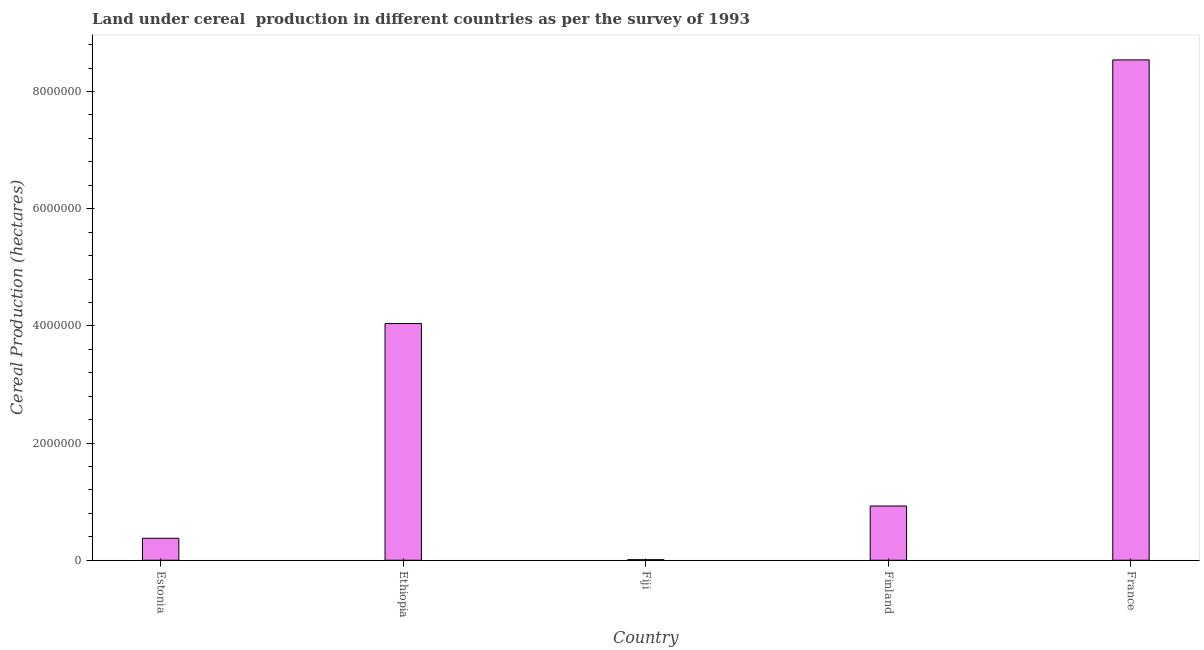Does the graph contain grids?
Keep it short and to the point. No. What is the title of the graph?
Offer a terse response. Land under cereal  production in different countries as per the survey of 1993. What is the label or title of the Y-axis?
Your answer should be compact. Cereal Production (hectares). What is the land under cereal production in Finland?
Provide a short and direct response. 9.26e+05. Across all countries, what is the maximum land under cereal production?
Offer a very short reply. 8.54e+06. Across all countries, what is the minimum land under cereal production?
Provide a short and direct response. 1.00e+04. In which country was the land under cereal production maximum?
Provide a succinct answer. France. In which country was the land under cereal production minimum?
Your response must be concise. Fiji. What is the sum of the land under cereal production?
Provide a short and direct response. 1.39e+07. What is the difference between the land under cereal production in Ethiopia and France?
Offer a very short reply. -4.50e+06. What is the average land under cereal production per country?
Offer a terse response. 2.78e+06. What is the median land under cereal production?
Ensure brevity in your answer.  9.26e+05. In how many countries, is the land under cereal production greater than 6400000 hectares?
Keep it short and to the point. 1. What is the ratio of the land under cereal production in Finland to that in France?
Give a very brief answer. 0.11. Is the difference between the land under cereal production in Ethiopia and Finland greater than the difference between any two countries?
Ensure brevity in your answer.  No. What is the difference between the highest and the second highest land under cereal production?
Ensure brevity in your answer.  4.50e+06. What is the difference between the highest and the lowest land under cereal production?
Your response must be concise. 8.53e+06. In how many countries, is the land under cereal production greater than the average land under cereal production taken over all countries?
Offer a very short reply. 2. Are all the bars in the graph horizontal?
Offer a very short reply. No. How many countries are there in the graph?
Your response must be concise. 5. What is the difference between two consecutive major ticks on the Y-axis?
Offer a very short reply. 2.00e+06. What is the Cereal Production (hectares) of Estonia?
Your answer should be compact. 3.75e+05. What is the Cereal Production (hectares) of Ethiopia?
Make the answer very short. 4.04e+06. What is the Cereal Production (hectares) of Fiji?
Your answer should be very brief. 1.00e+04. What is the Cereal Production (hectares) in Finland?
Make the answer very short. 9.26e+05. What is the Cereal Production (hectares) of France?
Provide a short and direct response. 8.54e+06. What is the difference between the Cereal Production (hectares) in Estonia and Ethiopia?
Offer a very short reply. -3.67e+06. What is the difference between the Cereal Production (hectares) in Estonia and Fiji?
Offer a terse response. 3.65e+05. What is the difference between the Cereal Production (hectares) in Estonia and Finland?
Ensure brevity in your answer.  -5.51e+05. What is the difference between the Cereal Production (hectares) in Estonia and France?
Ensure brevity in your answer.  -8.17e+06. What is the difference between the Cereal Production (hectares) in Ethiopia and Fiji?
Offer a very short reply. 4.03e+06. What is the difference between the Cereal Production (hectares) in Ethiopia and Finland?
Ensure brevity in your answer.  3.11e+06. What is the difference between the Cereal Production (hectares) in Ethiopia and France?
Give a very brief answer. -4.50e+06. What is the difference between the Cereal Production (hectares) in Fiji and Finland?
Offer a very short reply. -9.16e+05. What is the difference between the Cereal Production (hectares) in Fiji and France?
Provide a short and direct response. -8.53e+06. What is the difference between the Cereal Production (hectares) in Finland and France?
Your answer should be very brief. -7.61e+06. What is the ratio of the Cereal Production (hectares) in Estonia to that in Ethiopia?
Your answer should be compact. 0.09. What is the ratio of the Cereal Production (hectares) in Estonia to that in Fiji?
Give a very brief answer. 37.37. What is the ratio of the Cereal Production (hectares) in Estonia to that in Finland?
Make the answer very short. 0.41. What is the ratio of the Cereal Production (hectares) in Estonia to that in France?
Provide a succinct answer. 0.04. What is the ratio of the Cereal Production (hectares) in Ethiopia to that in Fiji?
Provide a short and direct response. 402.38. What is the ratio of the Cereal Production (hectares) in Ethiopia to that in Finland?
Offer a very short reply. 4.36. What is the ratio of the Cereal Production (hectares) in Ethiopia to that in France?
Your answer should be compact. 0.47. What is the ratio of the Cereal Production (hectares) in Fiji to that in Finland?
Your response must be concise. 0.01. What is the ratio of the Cereal Production (hectares) in Finland to that in France?
Your answer should be very brief. 0.11. 